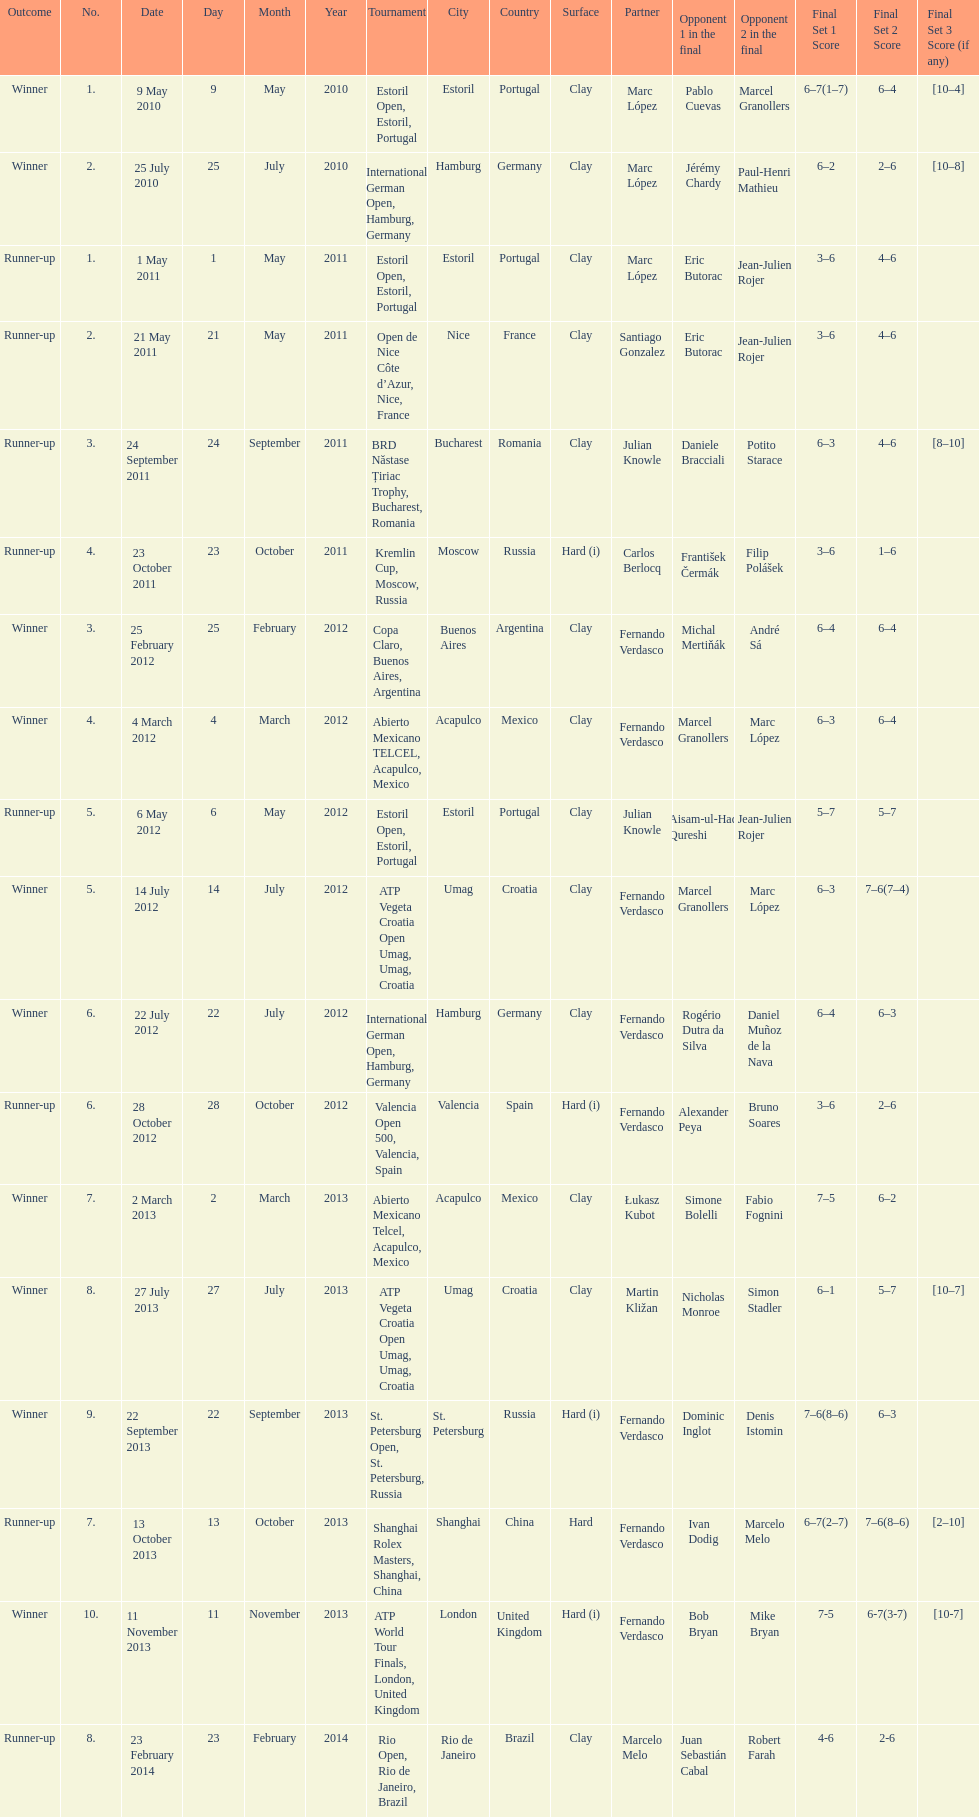Which tournament has the largest number? ATP World Tour Finals. 